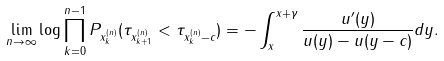<formula> <loc_0><loc_0><loc_500><loc_500>\lim _ { n \to \infty } \log \prod _ { k = 0 } ^ { n - 1 } P _ { x ^ { ( n ) } _ { k } } ( \tau _ { x ^ { ( n ) } _ { k + 1 } } < \tau _ { x ^ { ( n ) } _ { k } - c } ) = - \int _ { x } ^ { x + \gamma } \frac { u ^ { \prime } ( y ) } { u ( y ) - u ( y - c ) } d y .</formula> 